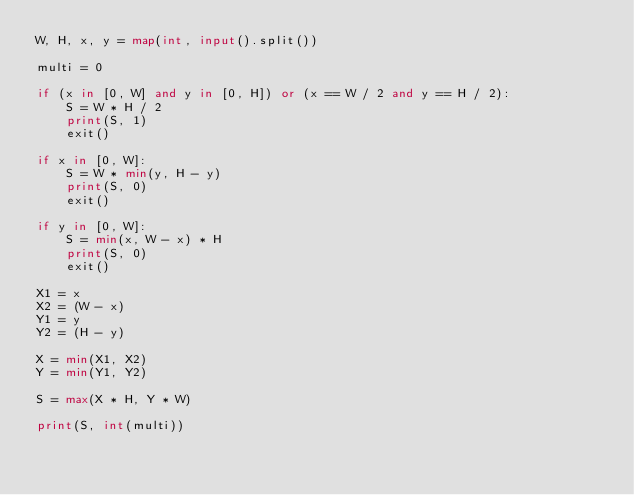Convert code to text. <code><loc_0><loc_0><loc_500><loc_500><_Python_>W, H, x, y = map(int, input().split())

multi = 0

if (x in [0, W] and y in [0, H]) or (x == W / 2 and y == H / 2):
    S = W * H / 2
    print(S, 1)
    exit()

if x in [0, W]:
    S = W * min(y, H - y)
    print(S, 0)
    exit()

if y in [0, W]:
    S = min(x, W - x) * H
    print(S, 0)
    exit()

X1 = x
X2 = (W - x)
Y1 = y
Y2 = (H - y)

X = min(X1, X2)
Y = min(Y1, Y2)

S = max(X * H, Y * W)

print(S, int(multi))
</code> 